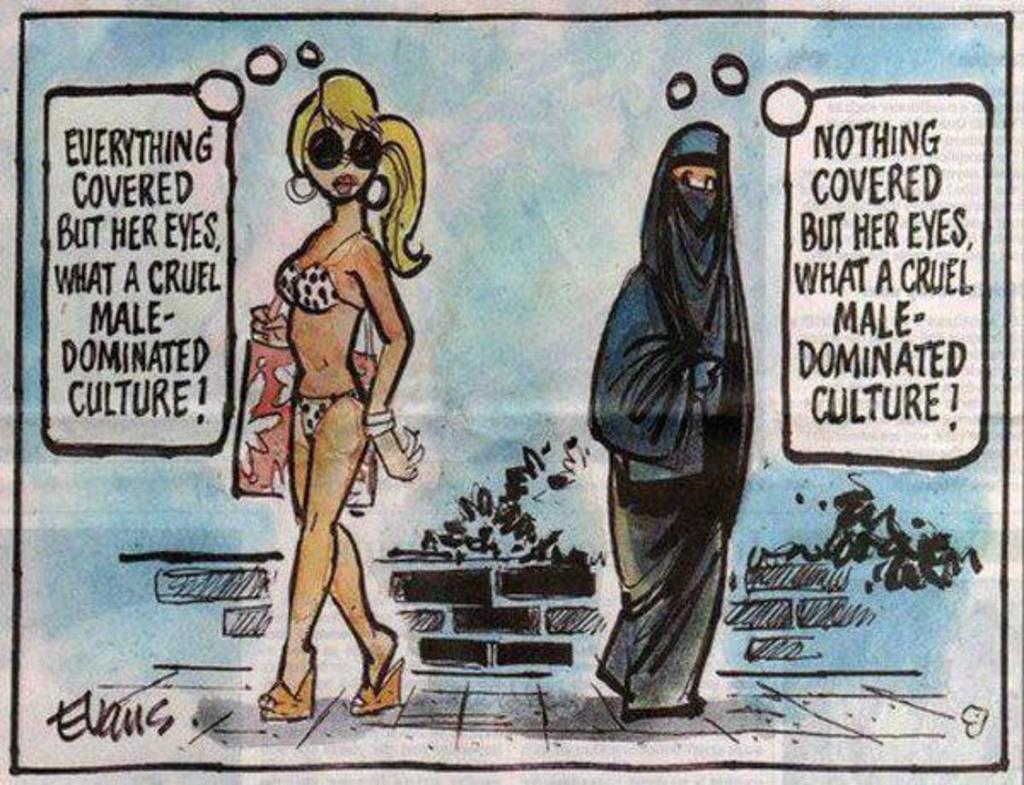In one or two sentences, can you explain what this image depicts? In this image we can see a painting of two women standing on the floor. One woman is carrying a bag in her hand. 